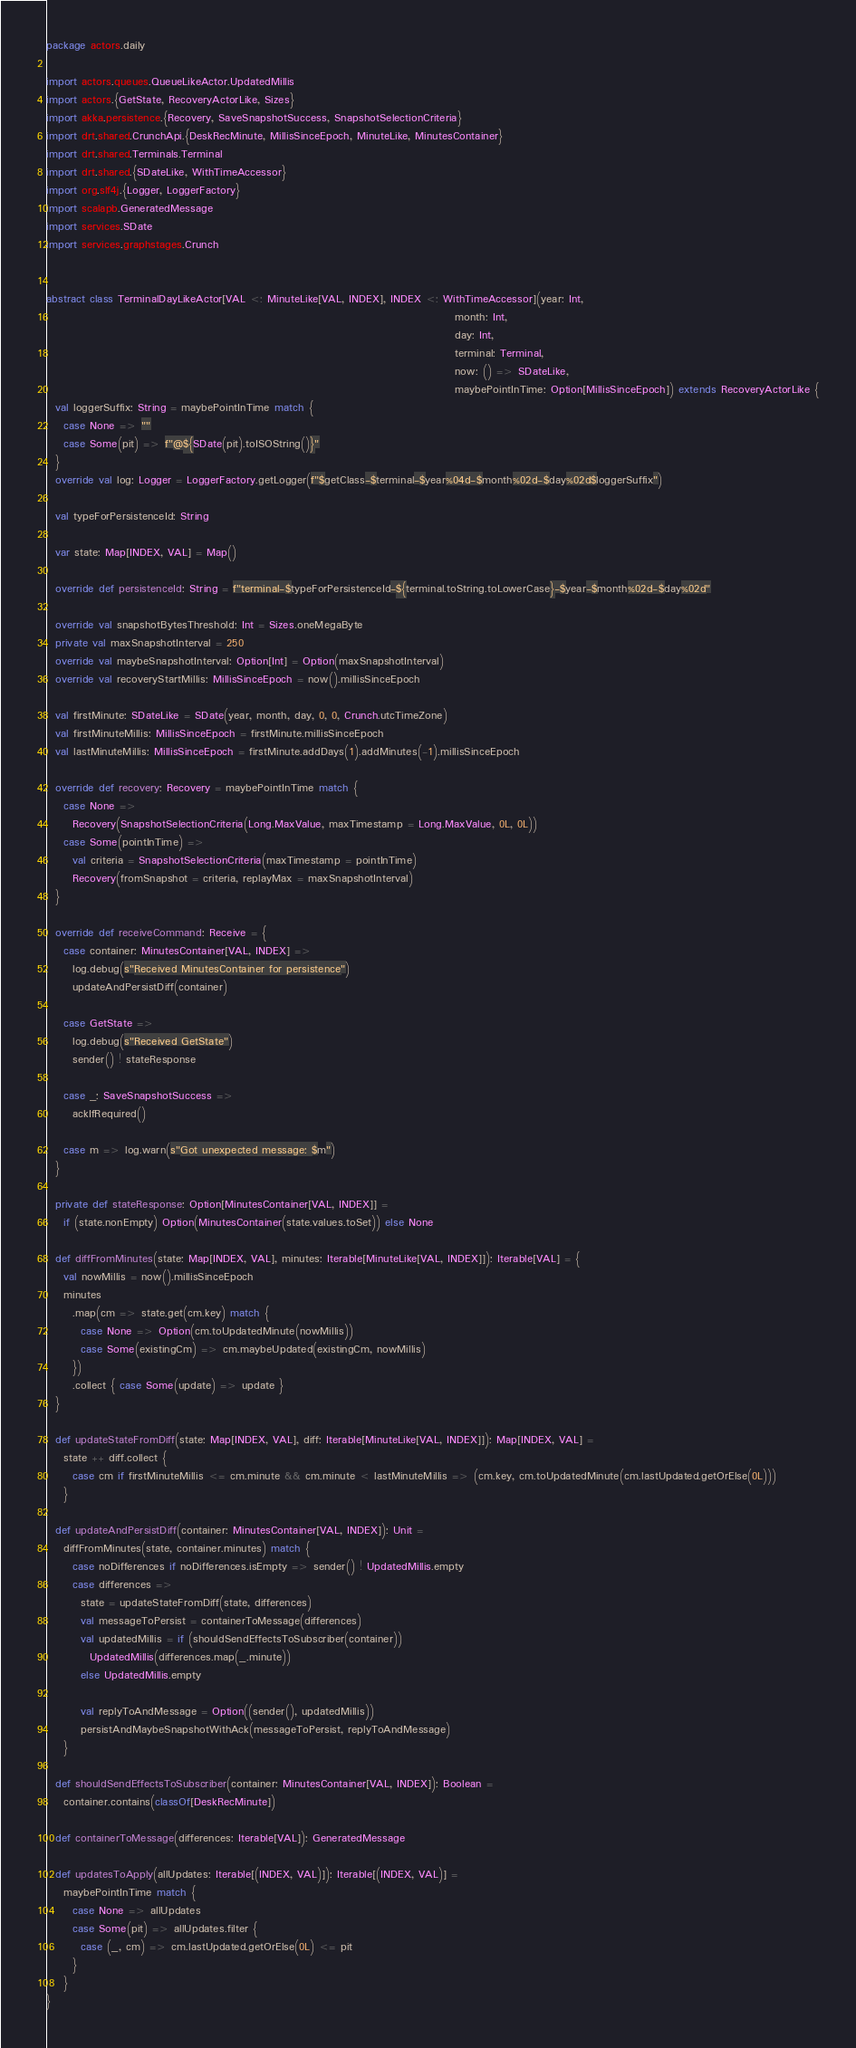Convert code to text. <code><loc_0><loc_0><loc_500><loc_500><_Scala_>package actors.daily

import actors.queues.QueueLikeActor.UpdatedMillis
import actors.{GetState, RecoveryActorLike, Sizes}
import akka.persistence.{Recovery, SaveSnapshotSuccess, SnapshotSelectionCriteria}
import drt.shared.CrunchApi.{DeskRecMinute, MillisSinceEpoch, MinuteLike, MinutesContainer}
import drt.shared.Terminals.Terminal
import drt.shared.{SDateLike, WithTimeAccessor}
import org.slf4j.{Logger, LoggerFactory}
import scalapb.GeneratedMessage
import services.SDate
import services.graphstages.Crunch


abstract class TerminalDayLikeActor[VAL <: MinuteLike[VAL, INDEX], INDEX <: WithTimeAccessor](year: Int,
                                                                                              month: Int,
                                                                                              day: Int,
                                                                                              terminal: Terminal,
                                                                                              now: () => SDateLike,
                                                                                              maybePointInTime: Option[MillisSinceEpoch]) extends RecoveryActorLike {
  val loggerSuffix: String = maybePointInTime match {
    case None => ""
    case Some(pit) => f"@${SDate(pit).toISOString()}"
  }
  override val log: Logger = LoggerFactory.getLogger(f"$getClass-$terminal-$year%04d-$month%02d-$day%02d$loggerSuffix")

  val typeForPersistenceId: String

  var state: Map[INDEX, VAL] = Map()

  override def persistenceId: String = f"terminal-$typeForPersistenceId-${terminal.toString.toLowerCase}-$year-$month%02d-$day%02d"

  override val snapshotBytesThreshold: Int = Sizes.oneMegaByte
  private val maxSnapshotInterval = 250
  override val maybeSnapshotInterval: Option[Int] = Option(maxSnapshotInterval)
  override val recoveryStartMillis: MillisSinceEpoch = now().millisSinceEpoch

  val firstMinute: SDateLike = SDate(year, month, day, 0, 0, Crunch.utcTimeZone)
  val firstMinuteMillis: MillisSinceEpoch = firstMinute.millisSinceEpoch
  val lastMinuteMillis: MillisSinceEpoch = firstMinute.addDays(1).addMinutes(-1).millisSinceEpoch

  override def recovery: Recovery = maybePointInTime match {
    case None =>
      Recovery(SnapshotSelectionCriteria(Long.MaxValue, maxTimestamp = Long.MaxValue, 0L, 0L))
    case Some(pointInTime) =>
      val criteria = SnapshotSelectionCriteria(maxTimestamp = pointInTime)
      Recovery(fromSnapshot = criteria, replayMax = maxSnapshotInterval)
  }

  override def receiveCommand: Receive = {
    case container: MinutesContainer[VAL, INDEX] =>
      log.debug(s"Received MinutesContainer for persistence")
      updateAndPersistDiff(container)

    case GetState =>
      log.debug(s"Received GetState")
      sender() ! stateResponse

    case _: SaveSnapshotSuccess =>
      ackIfRequired()

    case m => log.warn(s"Got unexpected message: $m")
  }

  private def stateResponse: Option[MinutesContainer[VAL, INDEX]] =
    if (state.nonEmpty) Option(MinutesContainer(state.values.toSet)) else None

  def diffFromMinutes(state: Map[INDEX, VAL], minutes: Iterable[MinuteLike[VAL, INDEX]]): Iterable[VAL] = {
    val nowMillis = now().millisSinceEpoch
    minutes
      .map(cm => state.get(cm.key) match {
        case None => Option(cm.toUpdatedMinute(nowMillis))
        case Some(existingCm) => cm.maybeUpdated(existingCm, nowMillis)
      })
      .collect { case Some(update) => update }
  }

  def updateStateFromDiff(state: Map[INDEX, VAL], diff: Iterable[MinuteLike[VAL, INDEX]]): Map[INDEX, VAL] =
    state ++ diff.collect {
      case cm if firstMinuteMillis <= cm.minute && cm.minute < lastMinuteMillis => (cm.key, cm.toUpdatedMinute(cm.lastUpdated.getOrElse(0L)))
    }

  def updateAndPersistDiff(container: MinutesContainer[VAL, INDEX]): Unit =
    diffFromMinutes(state, container.minutes) match {
      case noDifferences if noDifferences.isEmpty => sender() ! UpdatedMillis.empty
      case differences =>
        state = updateStateFromDiff(state, differences)
        val messageToPersist = containerToMessage(differences)
        val updatedMillis = if (shouldSendEffectsToSubscriber(container))
          UpdatedMillis(differences.map(_.minute))
        else UpdatedMillis.empty

        val replyToAndMessage = Option((sender(), updatedMillis))
        persistAndMaybeSnapshotWithAck(messageToPersist, replyToAndMessage)
    }

  def shouldSendEffectsToSubscriber(container: MinutesContainer[VAL, INDEX]): Boolean =
    container.contains(classOf[DeskRecMinute])

  def containerToMessage(differences: Iterable[VAL]): GeneratedMessage

  def updatesToApply(allUpdates: Iterable[(INDEX, VAL)]): Iterable[(INDEX, VAL)] =
    maybePointInTime match {
      case None => allUpdates
      case Some(pit) => allUpdates.filter {
        case (_, cm) => cm.lastUpdated.getOrElse(0L) <= pit
      }
    }
}
</code> 